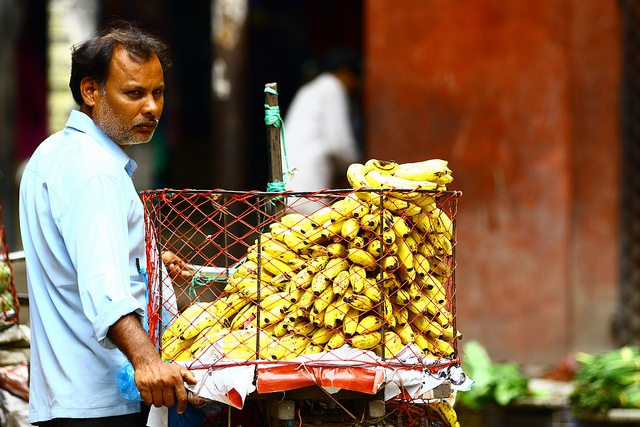Describe the objects in this image and their specific colors. I can see people in black, lightblue, and brown tones, banana in black, yellow, gold, khaki, and olive tones, and people in black, lightgray, darkgray, and gray tones in this image. 